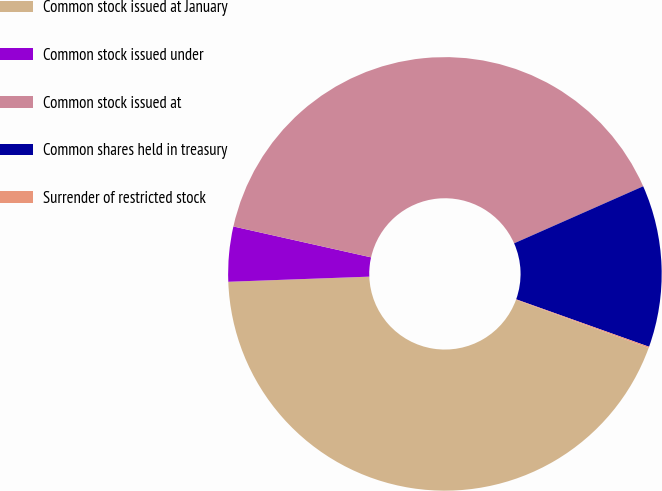<chart> <loc_0><loc_0><loc_500><loc_500><pie_chart><fcel>Common stock issued at January<fcel>Common stock issued under<fcel>Common stock issued at<fcel>Common shares held in treasury<fcel>Surrender of restricted stock<nl><fcel>43.87%<fcel>4.09%<fcel>39.87%<fcel>12.08%<fcel>0.1%<nl></chart> 